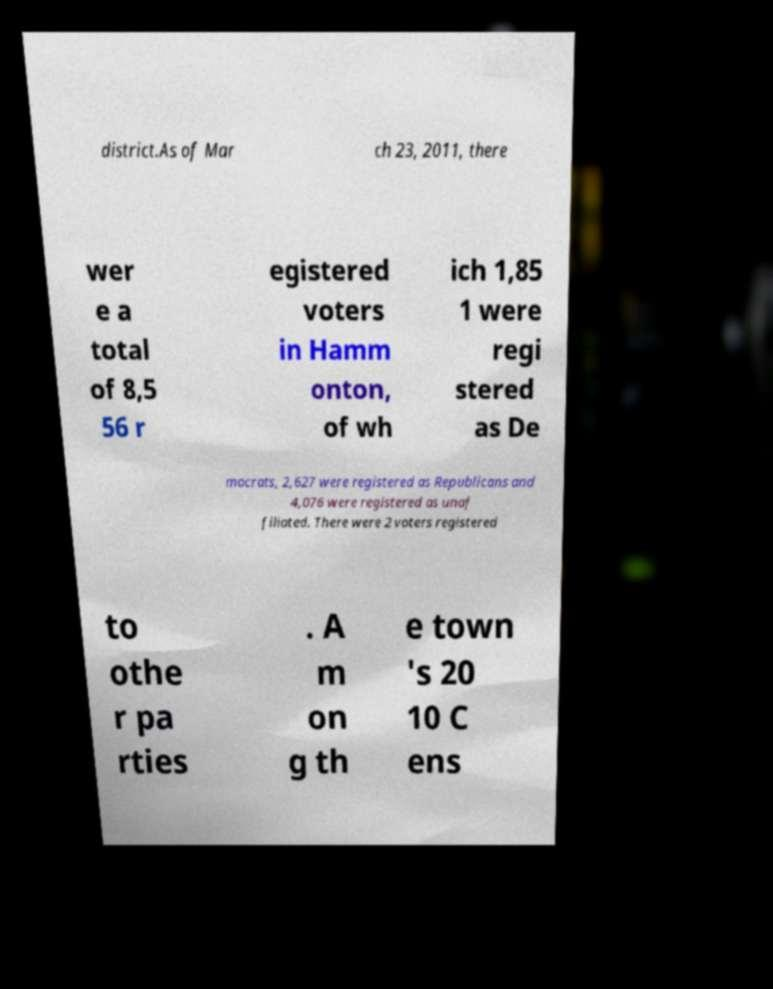What messages or text are displayed in this image? I need them in a readable, typed format. district.As of Mar ch 23, 2011, there wer e a total of 8,5 56 r egistered voters in Hamm onton, of wh ich 1,85 1 were regi stered as De mocrats, 2,627 were registered as Republicans and 4,076 were registered as unaf filiated. There were 2 voters registered to othe r pa rties . A m on g th e town 's 20 10 C ens 